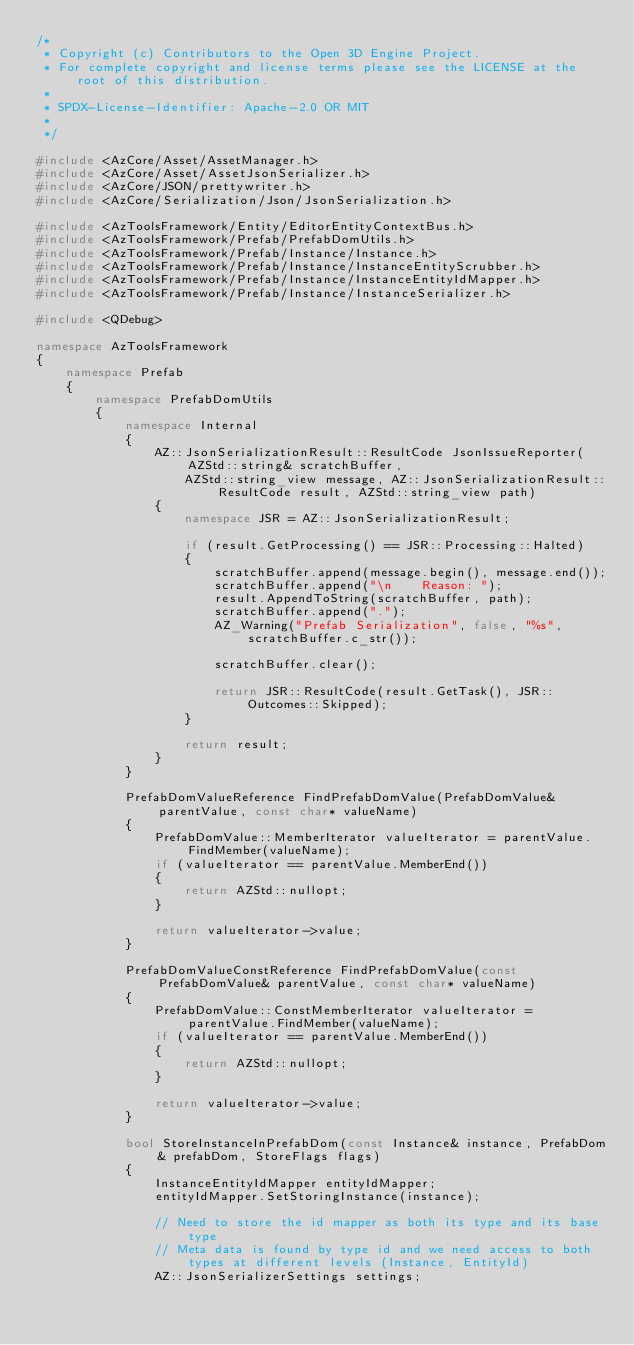<code> <loc_0><loc_0><loc_500><loc_500><_C++_>/*
 * Copyright (c) Contributors to the Open 3D Engine Project.
 * For complete copyright and license terms please see the LICENSE at the root of this distribution.
 *
 * SPDX-License-Identifier: Apache-2.0 OR MIT
 *
 */

#include <AzCore/Asset/AssetManager.h>
#include <AzCore/Asset/AssetJsonSerializer.h>
#include <AzCore/JSON/prettywriter.h>
#include <AzCore/Serialization/Json/JsonSerialization.h>

#include <AzToolsFramework/Entity/EditorEntityContextBus.h>
#include <AzToolsFramework/Prefab/PrefabDomUtils.h>
#include <AzToolsFramework/Prefab/Instance/Instance.h>
#include <AzToolsFramework/Prefab/Instance/InstanceEntityScrubber.h>
#include <AzToolsFramework/Prefab/Instance/InstanceEntityIdMapper.h>
#include <AzToolsFramework/Prefab/Instance/InstanceSerializer.h>

#include <QDebug>

namespace AzToolsFramework
{
    namespace Prefab
    {
        namespace PrefabDomUtils
        {
            namespace Internal
            {
                AZ::JsonSerializationResult::ResultCode JsonIssueReporter(AZStd::string& scratchBuffer,
                    AZStd::string_view message, AZ::JsonSerializationResult::ResultCode result, AZStd::string_view path)
                {
                    namespace JSR = AZ::JsonSerializationResult;

                    if (result.GetProcessing() == JSR::Processing::Halted)
                    {
                        scratchBuffer.append(message.begin(), message.end());
                        scratchBuffer.append("\n    Reason: ");
                        result.AppendToString(scratchBuffer, path);
                        scratchBuffer.append(".");
                        AZ_Warning("Prefab Serialization", false, "%s", scratchBuffer.c_str());

                        scratchBuffer.clear();

                        return JSR::ResultCode(result.GetTask(), JSR::Outcomes::Skipped);
                    }

                    return result;
                }
            }

            PrefabDomValueReference FindPrefabDomValue(PrefabDomValue& parentValue, const char* valueName)
            {
                PrefabDomValue::MemberIterator valueIterator = parentValue.FindMember(valueName);
                if (valueIterator == parentValue.MemberEnd())
                {
                    return AZStd::nullopt;
                }

                return valueIterator->value;
            }

            PrefabDomValueConstReference FindPrefabDomValue(const PrefabDomValue& parentValue, const char* valueName)
            {
                PrefabDomValue::ConstMemberIterator valueIterator = parentValue.FindMember(valueName);
                if (valueIterator == parentValue.MemberEnd())
                {
                    return AZStd::nullopt;
                }

                return valueIterator->value;
            }

            bool StoreInstanceInPrefabDom(const Instance& instance, PrefabDom& prefabDom, StoreFlags flags)
            {
                InstanceEntityIdMapper entityIdMapper;
                entityIdMapper.SetStoringInstance(instance);

                // Need to store the id mapper as both its type and its base type
                // Meta data is found by type id and we need access to both types at different levels (Instance, EntityId)
                AZ::JsonSerializerSettings settings;</code> 